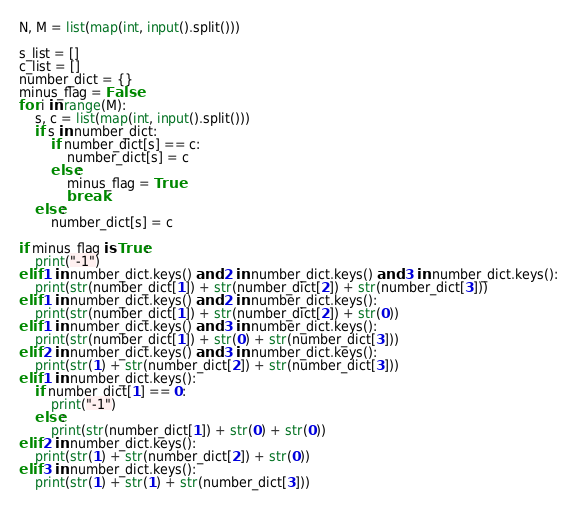<code> <loc_0><loc_0><loc_500><loc_500><_Python_>N, M = list(map(int, input().split()))

s_list = []
c_list = []
number_dict = {}
minus_flag = False
for i in range(M):
    s, c = list(map(int, input().split()))
    if s in number_dict:
        if number_dict[s] == c:
            number_dict[s] = c
        else:
            minus_flag = True
            break
    else:
        number_dict[s] = c

if minus_flag is True:
    print("-1")
elif 1 in number_dict.keys() and 2 in number_dict.keys() and 3 in number_dict.keys():
    print(str(number_dict[1]) + str(number_dict[2]) + str(number_dict[3]))
elif 1 in number_dict.keys() and 2 in number_dict.keys():
    print(str(number_dict[1]) + str(number_dict[2]) + str(0))
elif 1 in number_dict.keys() and 3 in number_dict.keys():
    print(str(number_dict[1]) + str(0) + str(number_dict[3]))
elif 2 in number_dict.keys() and 3 in number_dict.keys():
    print(str(1) + str(number_dict[2]) + str(number_dict[3]))
elif 1 in number_dict.keys():
    if number_dict[1] == 0:
        print("-1")
    else:
        print(str(number_dict[1]) + str(0) + str(0))
elif 2 in number_dict.keys():
    print(str(1) + str(number_dict[2]) + str(0))
elif 3 in number_dict.keys():
    print(str(1) + str(1) + str(number_dict[3]))</code> 